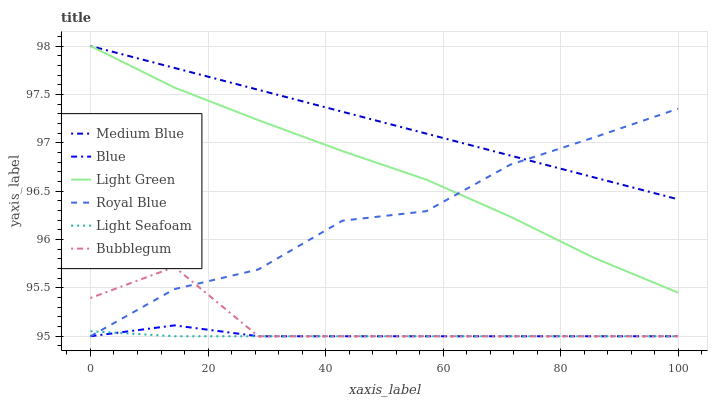Does Bubblegum have the minimum area under the curve?
Answer yes or no. No. Does Bubblegum have the maximum area under the curve?
Answer yes or no. No. Is Bubblegum the smoothest?
Answer yes or no. No. Is Medium Blue the roughest?
Answer yes or no. No. Does Medium Blue have the lowest value?
Answer yes or no. No. Does Bubblegum have the highest value?
Answer yes or no. No. Is Blue less than Medium Blue?
Answer yes or no. Yes. Is Medium Blue greater than Blue?
Answer yes or no. Yes. Does Blue intersect Medium Blue?
Answer yes or no. No. 